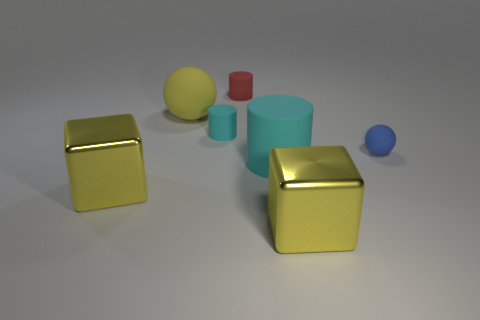Add 3 large blue matte objects. How many objects exist? 10 Subtract all cylinders. How many objects are left? 4 Add 6 blue things. How many blue things are left? 7 Add 1 large rubber balls. How many large rubber balls exist? 2 Subtract 2 yellow blocks. How many objects are left? 5 Subtract all metal objects. Subtract all red cylinders. How many objects are left? 4 